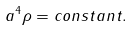<formula> <loc_0><loc_0><loc_500><loc_500>a ^ { 4 } \rho = c o n s t a n t .</formula> 